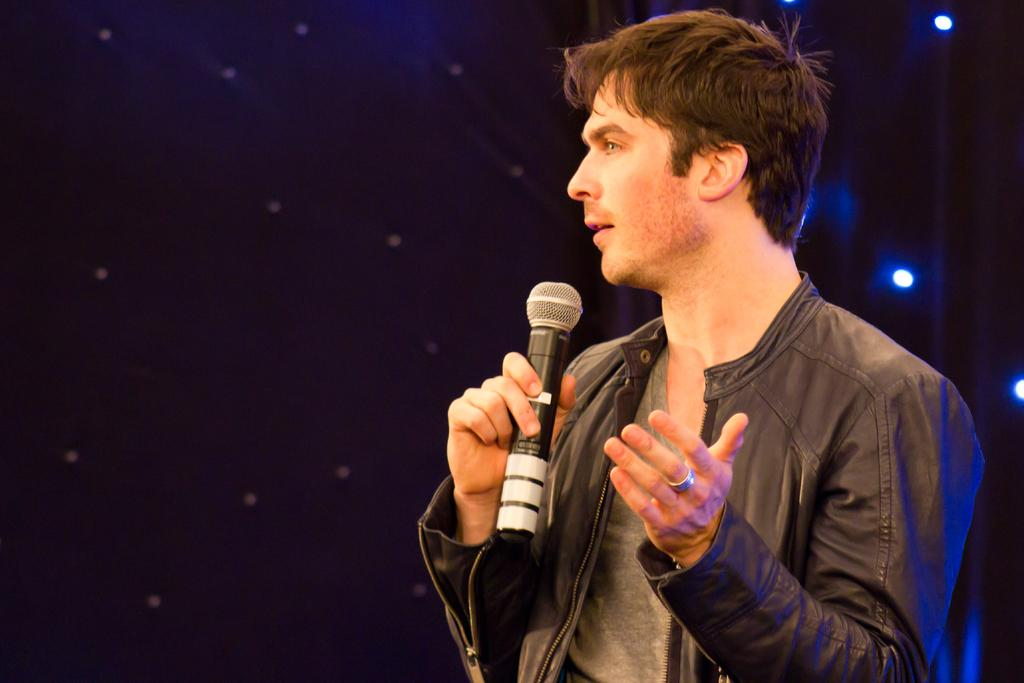Who is present in the image? There is a man in the image. What is the man wearing? The man is wearing a jacket. What is the man holding in his hand? The man is holding a mic in his hand. What type of nut can be seen on the boundary in the image? There is no nut or boundary present in the image; it features a man wearing a jacket and holding a mic. 